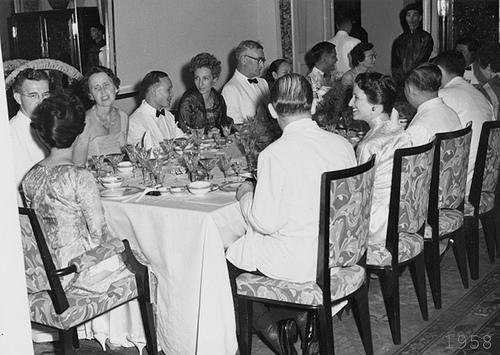What is the relationship between the people and objects in the image? The people in the image are interacting with objects, such as the table, chairs, and dinnerware, as they enjoy their meal and converse with one another. What is the primary hairstyle of most people in the image? Most people in the image have short dark hair. List the objects on the table in the image. On the table, there is a large white tablecloth, a plate, many low goblet-style drinking glasses, and a small white bowl. What is the general atmosphere of the scene in the image? The general atmosphere of the scene is a pleasant gathering of people having dinner together, with the presence of a dinner attendant to assist them. Describe one unique feature of the wooden chair in the image. The wooden chair has a decorative floral pattern on its high back. Explain what the dinner attendant in the image is waiting for. The dinner attendant is waiting to assist people having dinner. Mention the style of footwear a woman is wearing in the image. A woman in the image is wearing a pair of high heel shoes, specifically stilettos with pointed backs. What is the primary object of focus in this image and explain its appearance? The primary object of focus is a large dining table covered in a white tablecloth, with many people sitting around it and enjoying a meal. Describe the seating arrangement in the image. The seating arrangement consists of people sitting around a large dining table, with a wooden chair having a floral pattern and a padded right armrest. Give a short summary of the people and objects that are present in the image. The image includes people having dinner, a man in a white suit, a wooden chair with a floral pattern, many low goblet-style drinking glasses on the table, plates, and a large tablecloth-covered table. Find an open book lying on the table near the plate of food and tell what's written on it. No, it's not mentioned in the image. 